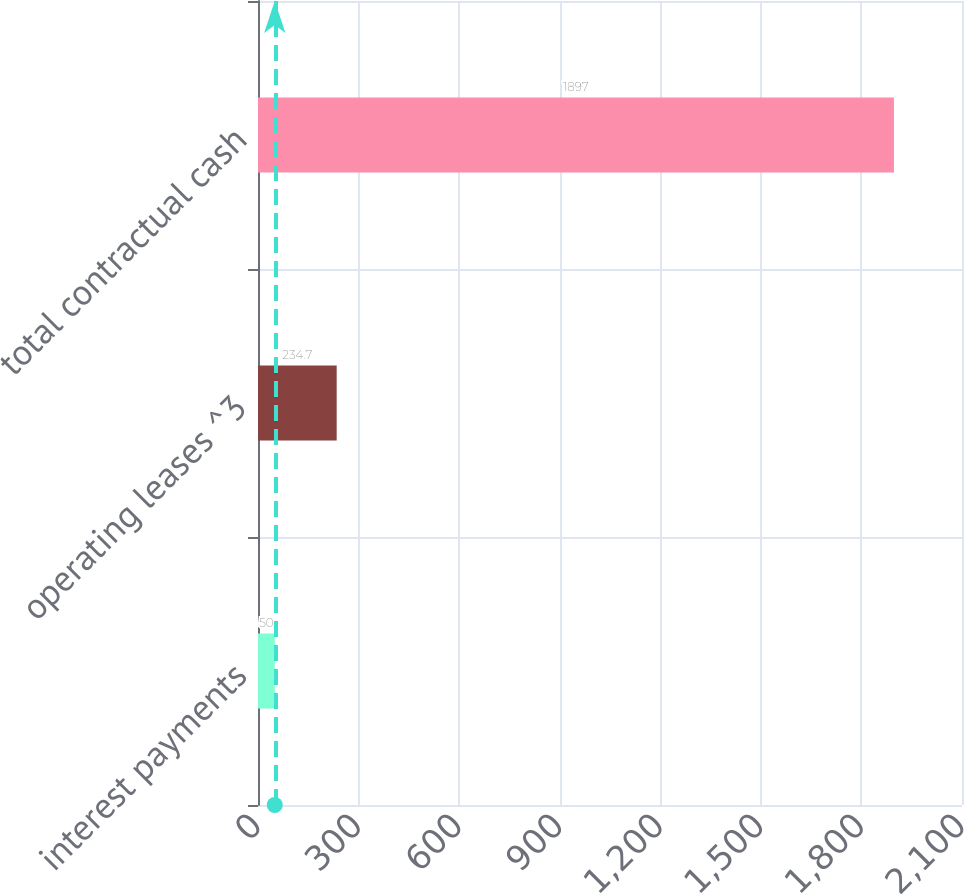<chart> <loc_0><loc_0><loc_500><loc_500><bar_chart><fcel>interest payments<fcel>operating leases ^3<fcel>total contractual cash<nl><fcel>50<fcel>234.7<fcel>1897<nl></chart> 